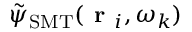Convert formula to latex. <formula><loc_0><loc_0><loc_500><loc_500>\tilde { \psi } _ { S M T } ( r _ { i } , \omega _ { k } )</formula> 